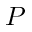<formula> <loc_0><loc_0><loc_500><loc_500>P</formula> 